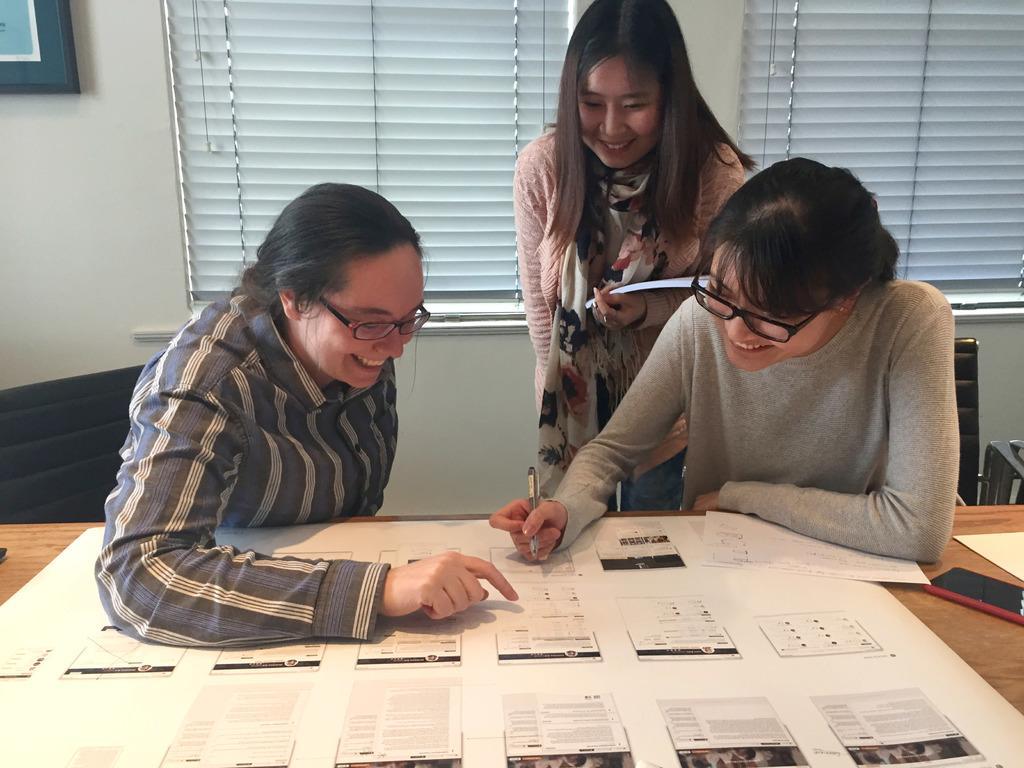Could you give a brief overview of what you see in this image? In the image in the center we can see one person standing and two persons were sitting. And they were smiling,which we can see on their faces. In front of them,there is a table. On the table,we can see papers and phone. In the background there is a wall,photo frame and window blind. 